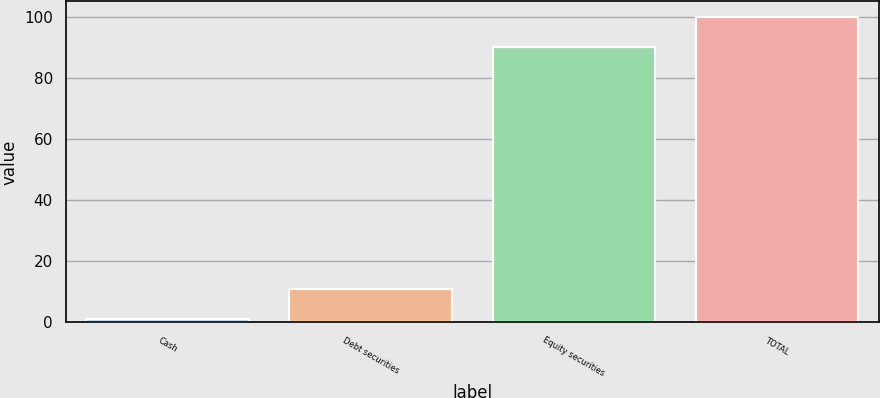Convert chart to OTSL. <chart><loc_0><loc_0><loc_500><loc_500><bar_chart><fcel>Cash<fcel>Debt securities<fcel>Equity securities<fcel>TOTAL<nl><fcel>1<fcel>10.9<fcel>90<fcel>100<nl></chart> 